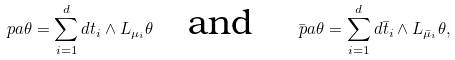<formula> <loc_0><loc_0><loc_500><loc_500>\ p a \theta = \sum _ { i = 1 } ^ { d } d t _ { i } \wedge L _ { \mu _ { i } } \theta \quad \text {and} \quad \bar { \ p a } \theta = \sum _ { i = 1 } ^ { d } d \bar { t } _ { i } \wedge L _ { \bar { \mu } _ { i } } \theta ,</formula> 